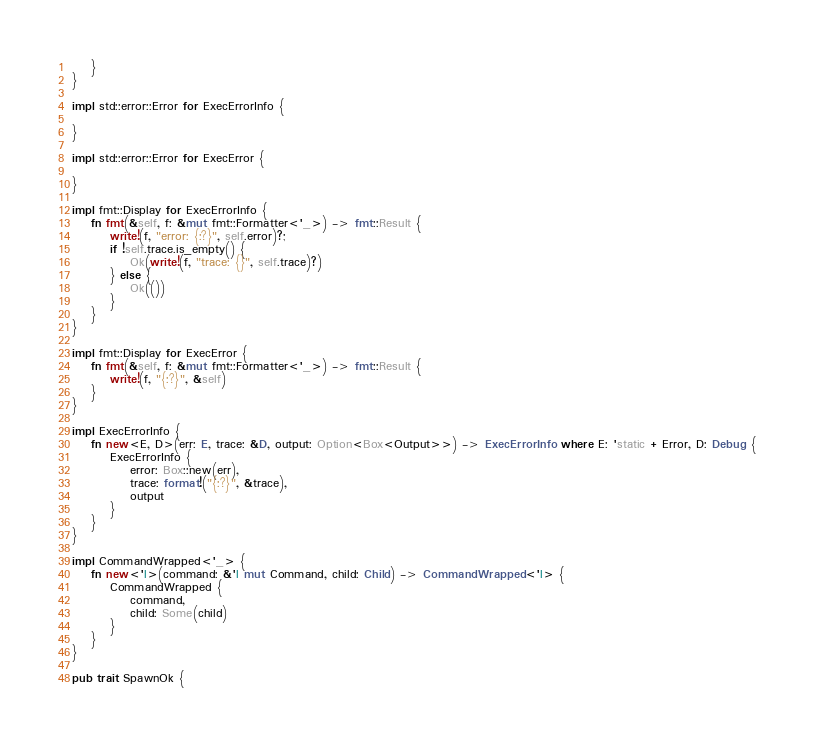Convert code to text. <code><loc_0><loc_0><loc_500><loc_500><_Rust_>    }
}

impl std::error::Error for ExecErrorInfo {

}

impl std::error::Error for ExecError {

}

impl fmt::Display for ExecErrorInfo {
    fn fmt(&self, f: &mut fmt::Formatter<'_>) -> fmt::Result {
        write!(f, "error: {:?}", self.error)?;
        if !self.trace.is_empty() {
            Ok(write!(f, "trace: {}", self.trace)?)
        } else {
            Ok(())
        }
    }
}

impl fmt::Display for ExecError {
    fn fmt(&self, f: &mut fmt::Formatter<'_>) -> fmt::Result {
        write!(f, "{:?}", &self)
    }
}

impl ExecErrorInfo {
    fn new<E, D>(err: E, trace: &D, output: Option<Box<Output>>) -> ExecErrorInfo where E: 'static + Error, D: Debug {
        ExecErrorInfo {
            error: Box::new(err),
            trace: format!("{:?}", &trace),
            output
        }
    }
}

impl CommandWrapped<'_> {
    fn new<'l>(command: &'l mut Command, child: Child) -> CommandWrapped<'l> {
        CommandWrapped {
            command,
            child: Some(child)
        }
    }
}

pub trait SpawnOk {</code> 